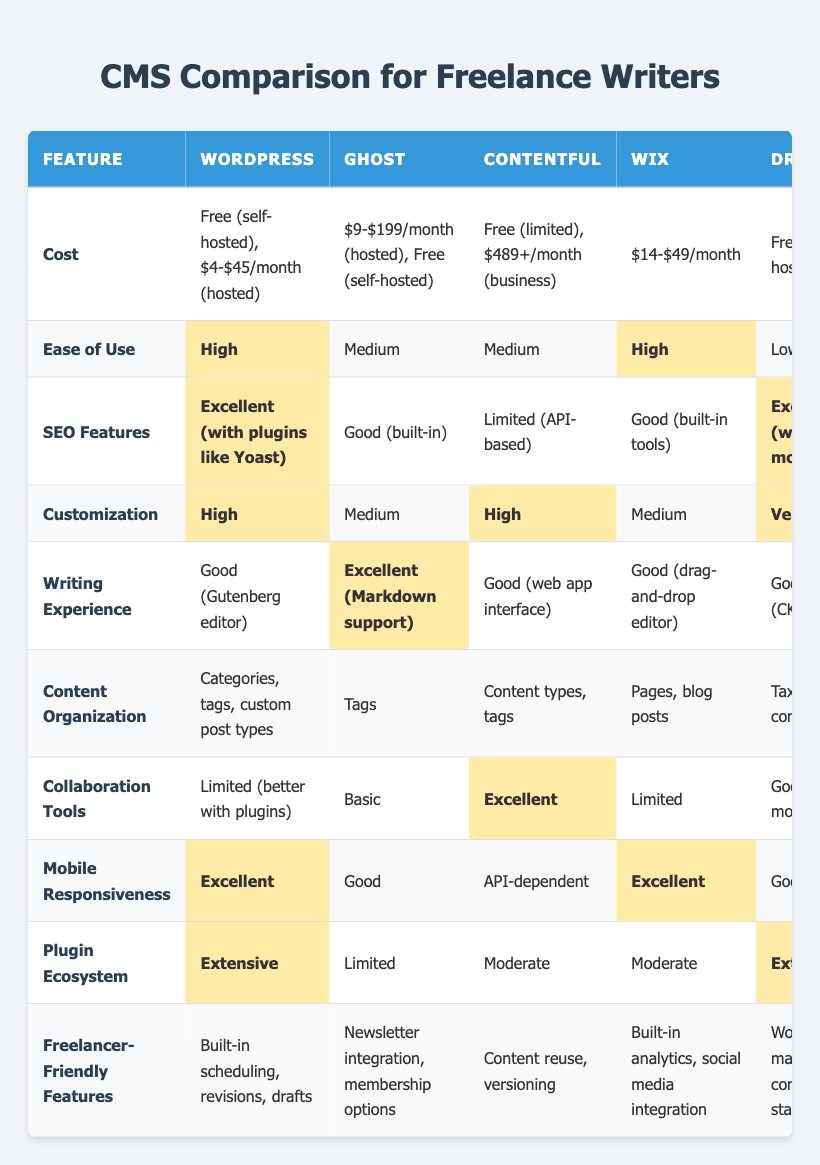What is the cost of using WordPress? The cost of using WordPress is listed as "Free (self-hosted), $4-$45/month (hosted)" in the table.
Answer: Free (self-hosted), $4-$45/month (hosted) Which CMS has the highest ease of use rating? The table indicates that both WordPress and Wix have a "High" ease of use.
Answer: WordPress and Wix Is Ghost's writing experience rated as good or excellent? The table states that Ghost has an "Excellent" writing experience due to its Markdown support.
Answer: Excellent What is the average cost of the CMSs listed? Adding the costs: (0 for self-hosted WordPress + 104 average for Ghost + 489 for Contentful + 31.5 for Wix + 0 for self-hosted Drupal) gives us a total of 624.5. For an accurate average among these five, considering only hosted options, the average cost is 104/4 = 26.
Answer: 26 Does Drupal have excellent SEO features? According to the table, Drupal has "Excellent (with modules)" SEO features.
Answer: Yes Which CMSs provide the most extensive plugin ecosystem? The table shows that both WordPress and Drupal boast an "Extensive" plugin ecosystem.
Answer: WordPress and Drupal What is the difference in customization rating between Contentful and Drupal? The customization for Contentful is "High," while for Drupal, it is "Very High." Thus, the difference is one rating level.
Answer: One rating level How many CMSs have limited collaboration tools? The table indicates that WordPress, Ghost, and Wix all have "Limited" collaboration tools. Counting these, we find three CMSs.
Answer: Three Which platform has built-in analytics features? From the table, it is indicated that Wix provides "Built-in analytics, social media integration" as freelancer-friendly features.
Answer: Wix 